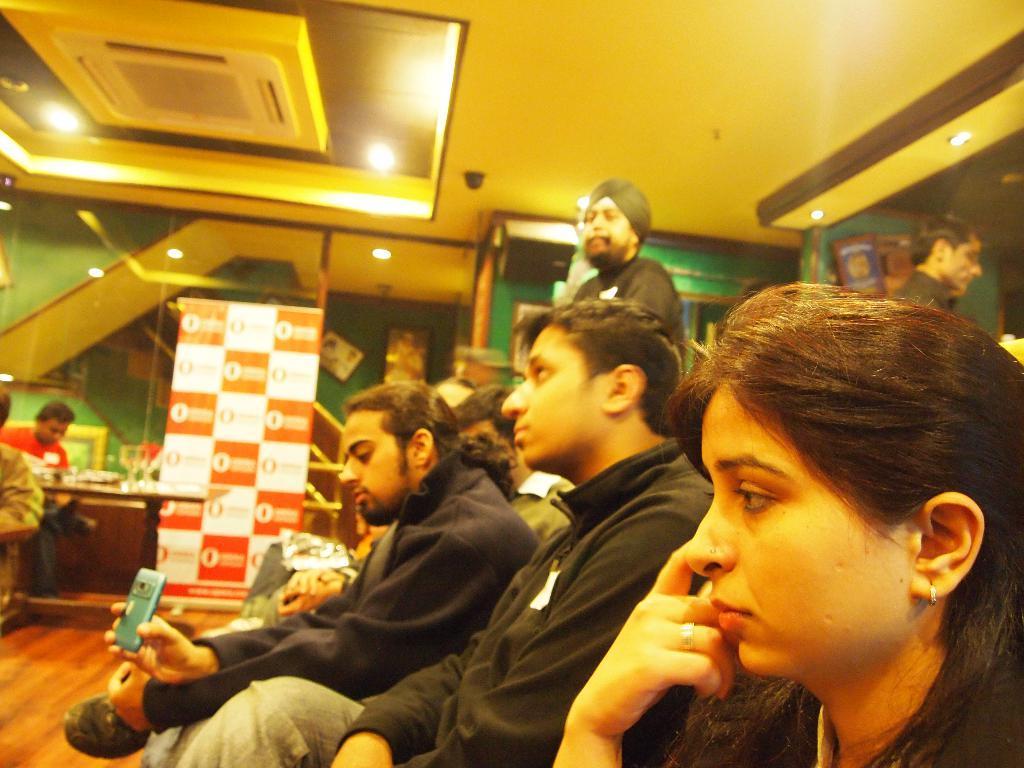Could you give a brief overview of what you see in this image? In this picture there are few persons sitting and there are two persons standing behind them and there is a central air conditioner attached to the roof above them and there are some other objects in the background. 